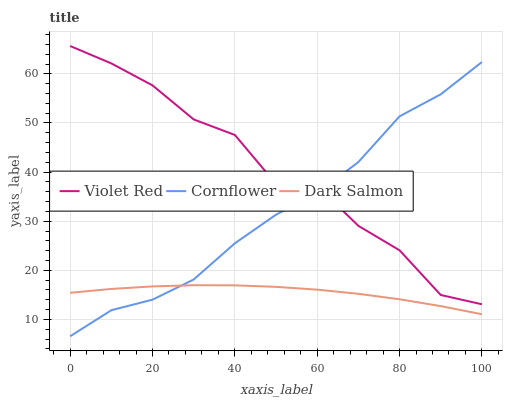Does Dark Salmon have the minimum area under the curve?
Answer yes or no. Yes. Does Violet Red have the maximum area under the curve?
Answer yes or no. Yes. Does Violet Red have the minimum area under the curve?
Answer yes or no. No. Does Dark Salmon have the maximum area under the curve?
Answer yes or no. No. Is Dark Salmon the smoothest?
Answer yes or no. Yes. Is Violet Red the roughest?
Answer yes or no. Yes. Is Violet Red the smoothest?
Answer yes or no. No. Is Dark Salmon the roughest?
Answer yes or no. No. Does Dark Salmon have the lowest value?
Answer yes or no. No. Does Dark Salmon have the highest value?
Answer yes or no. No. Is Dark Salmon less than Violet Red?
Answer yes or no. Yes. Is Violet Red greater than Dark Salmon?
Answer yes or no. Yes. Does Dark Salmon intersect Violet Red?
Answer yes or no. No. 